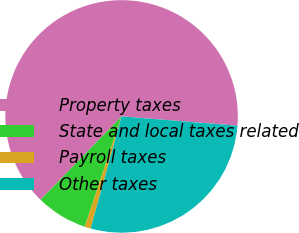<chart> <loc_0><loc_0><loc_500><loc_500><pie_chart><fcel>Property taxes<fcel>State and local taxes related<fcel>Payroll taxes<fcel>Other taxes<nl><fcel>63.99%<fcel>7.15%<fcel>0.84%<fcel>28.02%<nl></chart> 